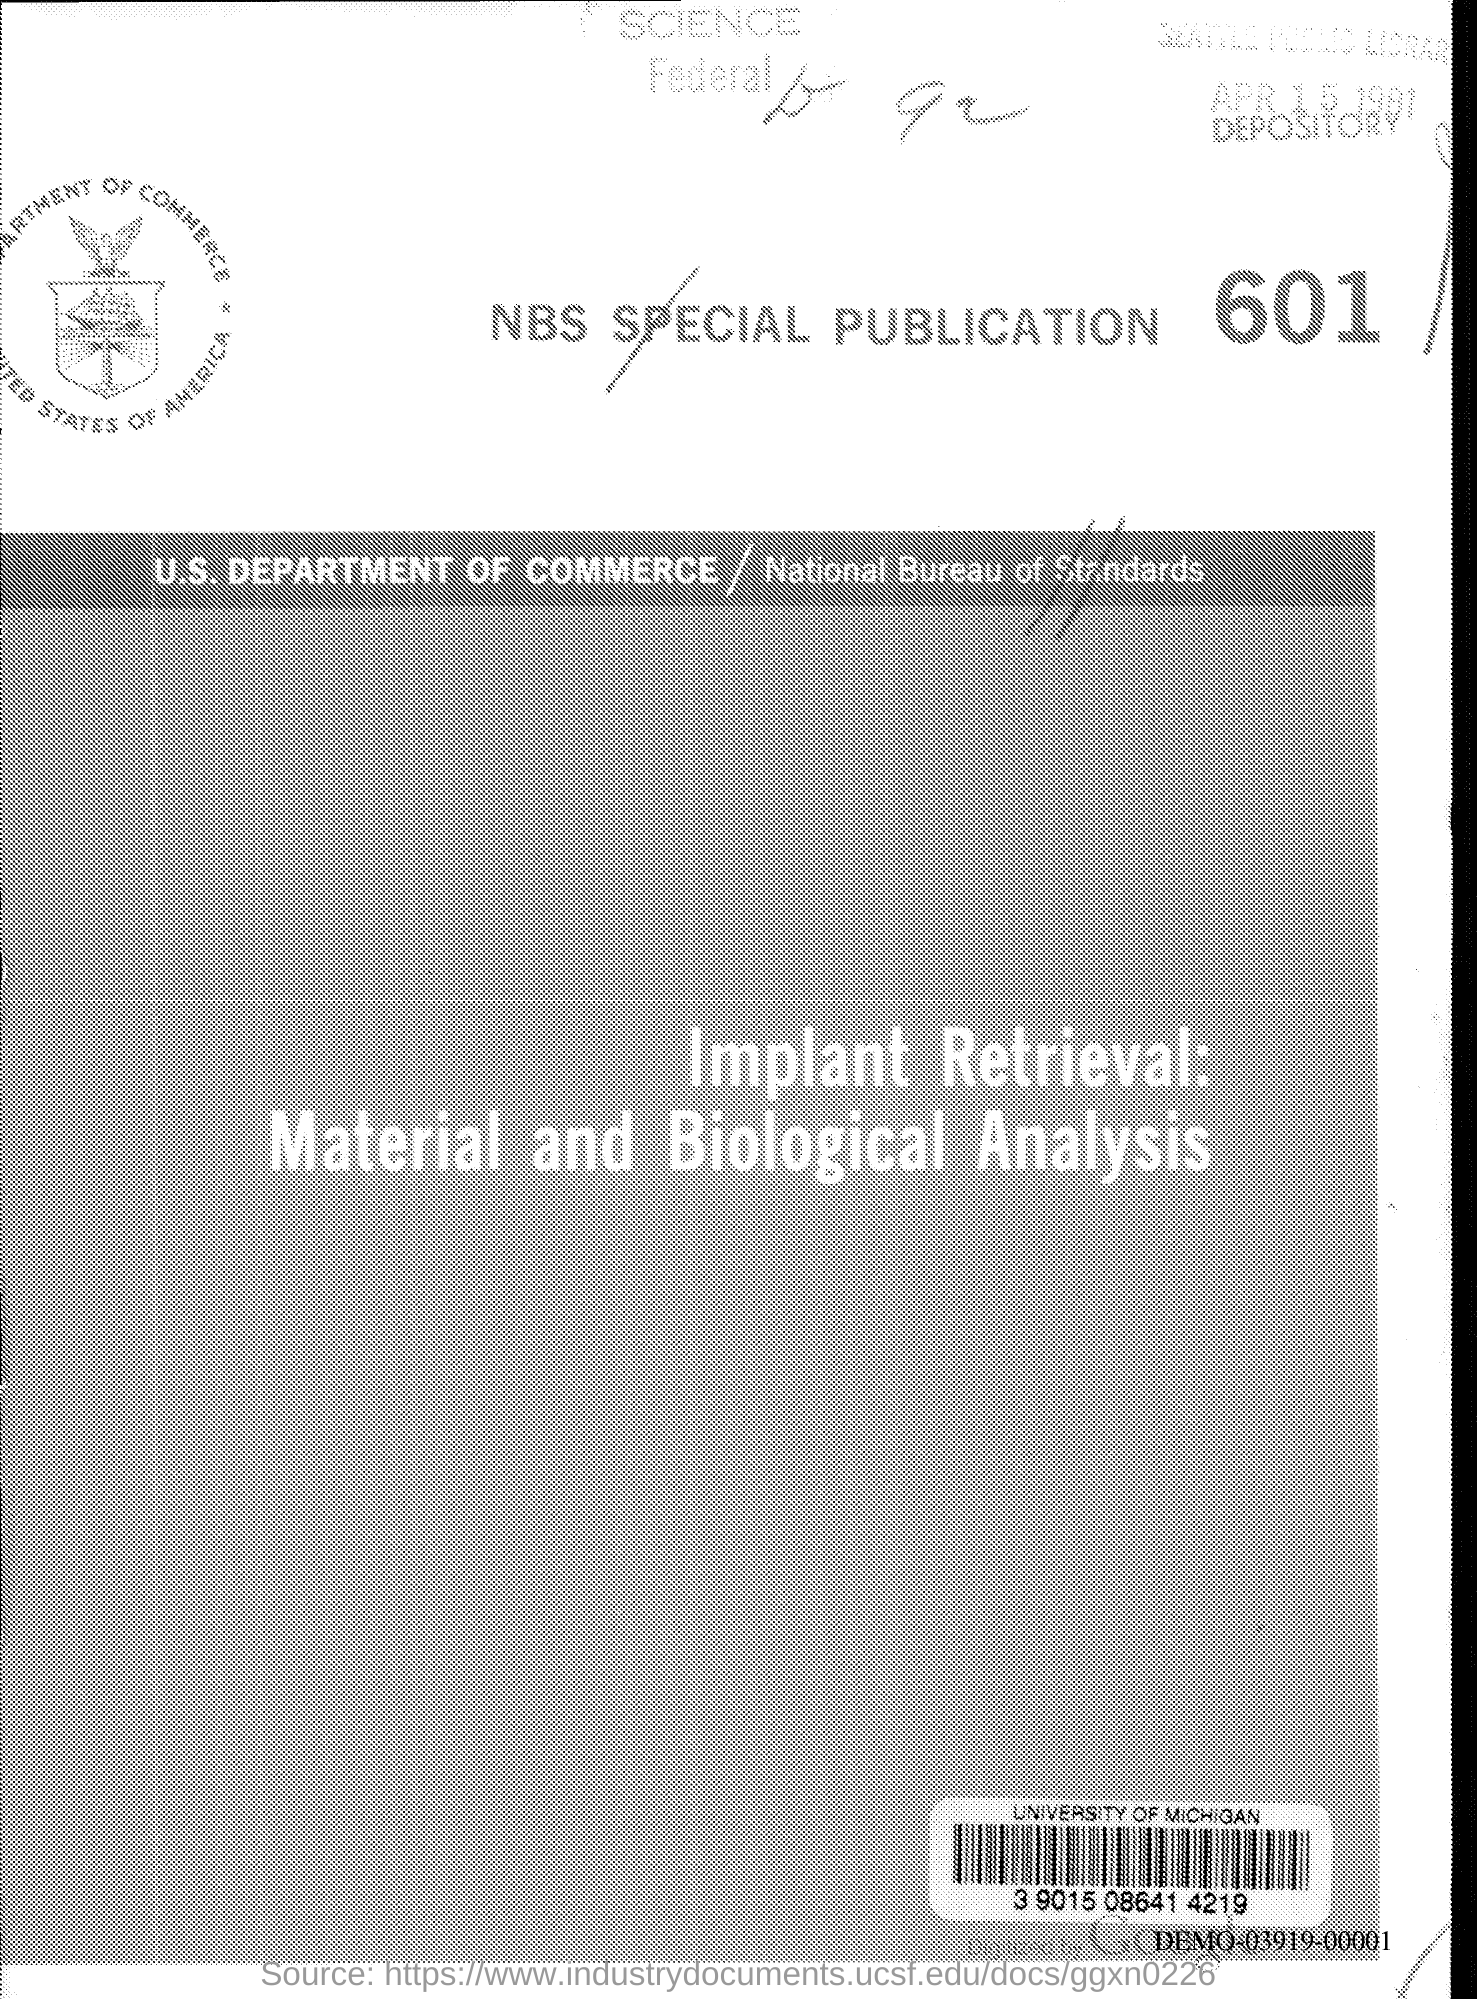What is the nbs special publication no.?
Ensure brevity in your answer.  601. 